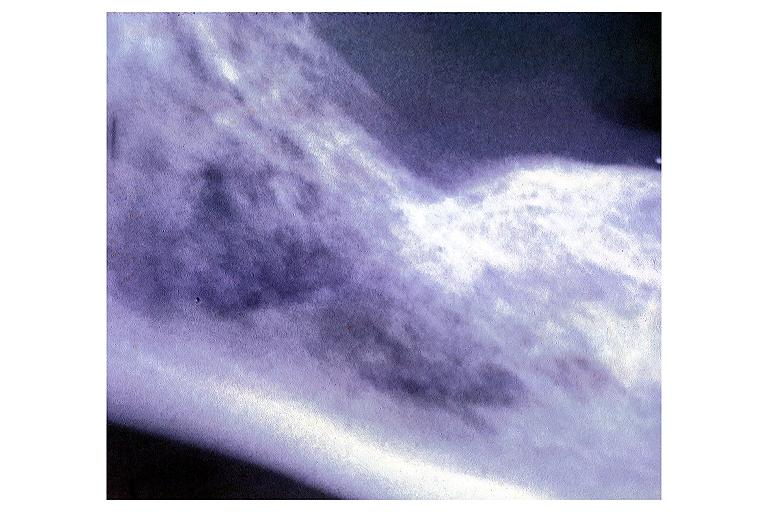s high excellent steroid present?
Answer the question using a single word or phrase. No 